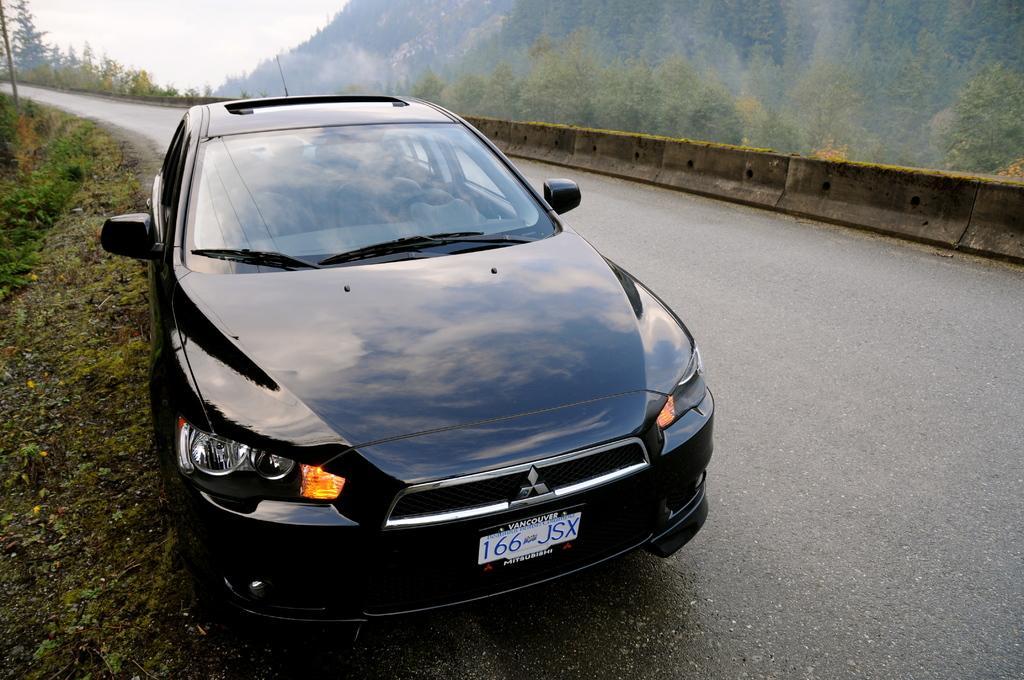Could you give a brief overview of what you see in this image? In this picture we can see a car on the road and in the background we can see trees,sky. 